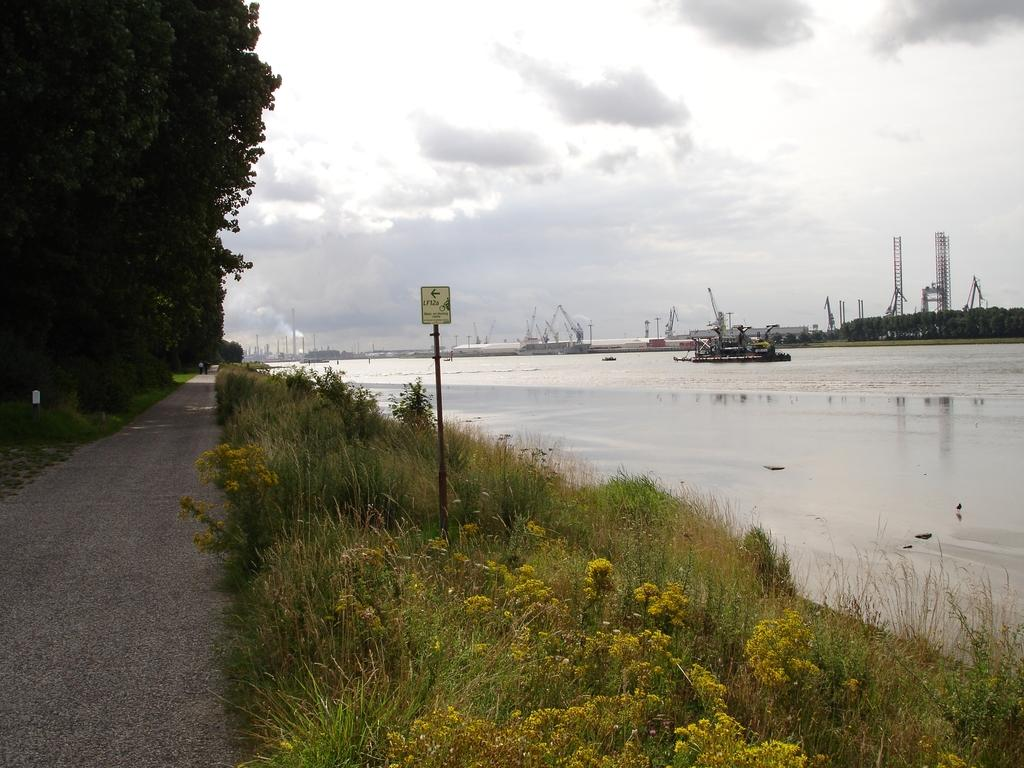What is located in the water in the image? There is a boat in the water in the image. What type of structures can be seen in the image? There are cranes in the image. What natural elements are present in the image? The image contains water, grass, trees, and a cloudy sky. What man-made structures are present in the image? There is a road, a pole, and a board in the image. What is the weather like in the image? The sky is cloudy in the image, and there is smoke present. What type of suit is the boat wearing in the image? Boats do not wear suits; they are inanimate objects. How does the stomach of the crane appear in the image? There are no crane stomachs visible in the image, as cranes are birds and not present in the image. 